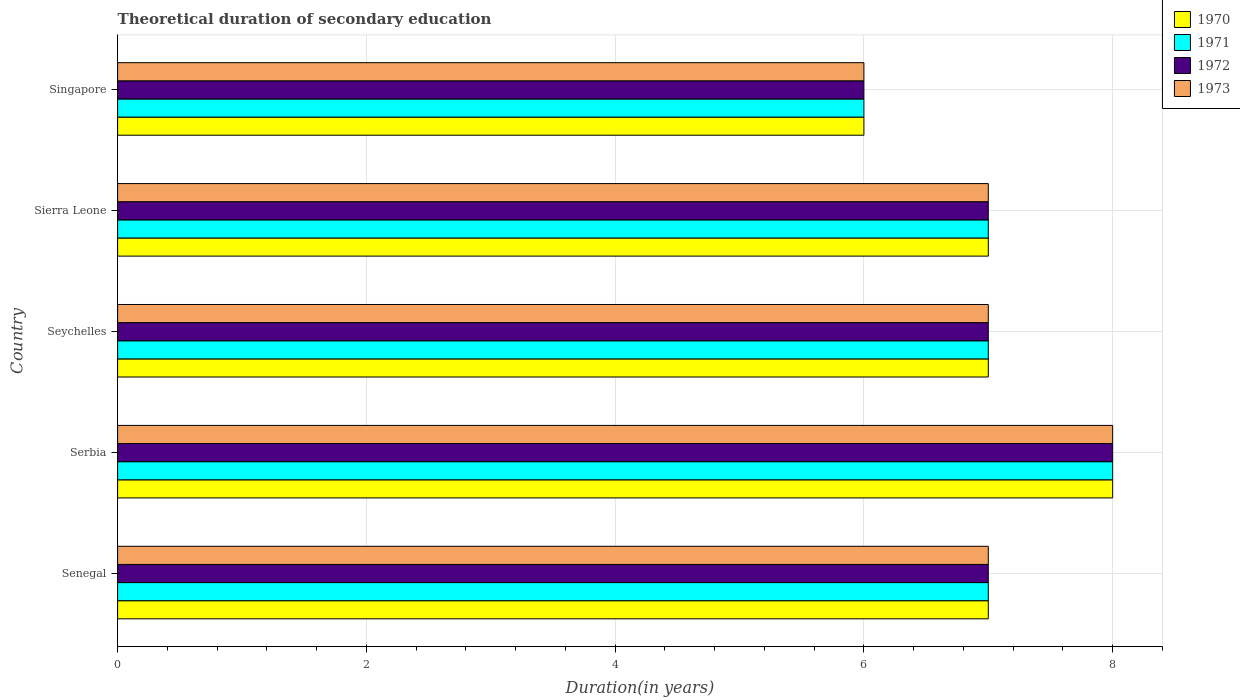How many groups of bars are there?
Offer a very short reply. 5. Are the number of bars per tick equal to the number of legend labels?
Keep it short and to the point. Yes. What is the label of the 1st group of bars from the top?
Make the answer very short. Singapore. Across all countries, what is the maximum total theoretical duration of secondary education in 1970?
Your answer should be very brief. 8. In which country was the total theoretical duration of secondary education in 1971 maximum?
Give a very brief answer. Serbia. In which country was the total theoretical duration of secondary education in 1973 minimum?
Your response must be concise. Singapore. What is the total total theoretical duration of secondary education in 1971 in the graph?
Your response must be concise. 35. In how many countries, is the total theoretical duration of secondary education in 1972 greater than 8 years?
Ensure brevity in your answer.  0. Is the total theoretical duration of secondary education in 1971 in Serbia less than that in Seychelles?
Make the answer very short. No. What is the difference between the highest and the second highest total theoretical duration of secondary education in 1971?
Your response must be concise. 1. What is the difference between the highest and the lowest total theoretical duration of secondary education in 1971?
Keep it short and to the point. 2. Is it the case that in every country, the sum of the total theoretical duration of secondary education in 1973 and total theoretical duration of secondary education in 1970 is greater than the sum of total theoretical duration of secondary education in 1972 and total theoretical duration of secondary education in 1971?
Offer a very short reply. No. What does the 3rd bar from the bottom in Senegal represents?
Keep it short and to the point. 1972. How many bars are there?
Give a very brief answer. 20. Are all the bars in the graph horizontal?
Provide a succinct answer. Yes. How many countries are there in the graph?
Provide a succinct answer. 5. Are the values on the major ticks of X-axis written in scientific E-notation?
Offer a very short reply. No. Where does the legend appear in the graph?
Ensure brevity in your answer.  Top right. How many legend labels are there?
Your response must be concise. 4. How are the legend labels stacked?
Give a very brief answer. Vertical. What is the title of the graph?
Make the answer very short. Theoretical duration of secondary education. Does "1992" appear as one of the legend labels in the graph?
Your answer should be compact. No. What is the label or title of the X-axis?
Offer a very short reply. Duration(in years). What is the label or title of the Y-axis?
Provide a short and direct response. Country. What is the Duration(in years) in 1971 in Senegal?
Make the answer very short. 7. What is the Duration(in years) in 1972 in Senegal?
Offer a terse response. 7. What is the Duration(in years) of 1972 in Serbia?
Offer a very short reply. 8. What is the Duration(in years) in 1972 in Seychelles?
Keep it short and to the point. 7. What is the Duration(in years) in 1973 in Seychelles?
Ensure brevity in your answer.  7. What is the Duration(in years) in 1971 in Sierra Leone?
Your answer should be very brief. 7. What is the Duration(in years) in 1972 in Sierra Leone?
Offer a terse response. 7. What is the Duration(in years) of 1970 in Singapore?
Your answer should be compact. 6. What is the Duration(in years) in 1973 in Singapore?
Make the answer very short. 6. Across all countries, what is the maximum Duration(in years) of 1970?
Your response must be concise. 8. Across all countries, what is the maximum Duration(in years) of 1971?
Give a very brief answer. 8. Across all countries, what is the maximum Duration(in years) in 1972?
Ensure brevity in your answer.  8. Across all countries, what is the minimum Duration(in years) of 1970?
Give a very brief answer. 6. What is the total Duration(in years) in 1972 in the graph?
Your answer should be compact. 35. What is the difference between the Duration(in years) in 1970 in Senegal and that in Serbia?
Offer a terse response. -1. What is the difference between the Duration(in years) in 1971 in Senegal and that in Serbia?
Ensure brevity in your answer.  -1. What is the difference between the Duration(in years) of 1972 in Senegal and that in Serbia?
Offer a terse response. -1. What is the difference between the Duration(in years) of 1973 in Senegal and that in Serbia?
Your answer should be compact. -1. What is the difference between the Duration(in years) in 1970 in Senegal and that in Seychelles?
Offer a terse response. 0. What is the difference between the Duration(in years) in 1971 in Senegal and that in Seychelles?
Provide a short and direct response. 0. What is the difference between the Duration(in years) in 1973 in Senegal and that in Seychelles?
Keep it short and to the point. 0. What is the difference between the Duration(in years) in 1971 in Senegal and that in Sierra Leone?
Offer a terse response. 0. What is the difference between the Duration(in years) of 1972 in Senegal and that in Sierra Leone?
Offer a terse response. 0. What is the difference between the Duration(in years) in 1970 in Senegal and that in Singapore?
Ensure brevity in your answer.  1. What is the difference between the Duration(in years) of 1973 in Senegal and that in Singapore?
Your answer should be very brief. 1. What is the difference between the Duration(in years) in 1971 in Serbia and that in Seychelles?
Your response must be concise. 1. What is the difference between the Duration(in years) of 1972 in Serbia and that in Seychelles?
Keep it short and to the point. 1. What is the difference between the Duration(in years) of 1970 in Serbia and that in Sierra Leone?
Ensure brevity in your answer.  1. What is the difference between the Duration(in years) of 1971 in Serbia and that in Sierra Leone?
Offer a very short reply. 1. What is the difference between the Duration(in years) of 1972 in Serbia and that in Sierra Leone?
Offer a terse response. 1. What is the difference between the Duration(in years) in 1971 in Serbia and that in Singapore?
Your answer should be compact. 2. What is the difference between the Duration(in years) of 1972 in Serbia and that in Singapore?
Your answer should be very brief. 2. What is the difference between the Duration(in years) of 1971 in Seychelles and that in Sierra Leone?
Provide a succinct answer. 0. What is the difference between the Duration(in years) of 1973 in Seychelles and that in Sierra Leone?
Offer a terse response. 0. What is the difference between the Duration(in years) of 1970 in Seychelles and that in Singapore?
Provide a short and direct response. 1. What is the difference between the Duration(in years) in 1971 in Seychelles and that in Singapore?
Your answer should be compact. 1. What is the difference between the Duration(in years) of 1973 in Seychelles and that in Singapore?
Make the answer very short. 1. What is the difference between the Duration(in years) of 1970 in Sierra Leone and that in Singapore?
Give a very brief answer. 1. What is the difference between the Duration(in years) in 1971 in Sierra Leone and that in Singapore?
Offer a terse response. 1. What is the difference between the Duration(in years) in 1970 in Senegal and the Duration(in years) in 1971 in Serbia?
Make the answer very short. -1. What is the difference between the Duration(in years) of 1970 in Senegal and the Duration(in years) of 1972 in Serbia?
Your answer should be very brief. -1. What is the difference between the Duration(in years) of 1970 in Senegal and the Duration(in years) of 1973 in Serbia?
Provide a succinct answer. -1. What is the difference between the Duration(in years) in 1971 in Senegal and the Duration(in years) in 1972 in Serbia?
Ensure brevity in your answer.  -1. What is the difference between the Duration(in years) in 1970 in Senegal and the Duration(in years) in 1971 in Seychelles?
Give a very brief answer. 0. What is the difference between the Duration(in years) in 1970 in Senegal and the Duration(in years) in 1973 in Seychelles?
Ensure brevity in your answer.  0. What is the difference between the Duration(in years) of 1972 in Senegal and the Duration(in years) of 1973 in Seychelles?
Your answer should be compact. 0. What is the difference between the Duration(in years) in 1971 in Senegal and the Duration(in years) in 1972 in Sierra Leone?
Give a very brief answer. 0. What is the difference between the Duration(in years) of 1971 in Senegal and the Duration(in years) of 1973 in Sierra Leone?
Ensure brevity in your answer.  0. What is the difference between the Duration(in years) in 1972 in Senegal and the Duration(in years) in 1973 in Sierra Leone?
Keep it short and to the point. 0. What is the difference between the Duration(in years) in 1970 in Senegal and the Duration(in years) in 1971 in Singapore?
Make the answer very short. 1. What is the difference between the Duration(in years) in 1971 in Senegal and the Duration(in years) in 1973 in Singapore?
Give a very brief answer. 1. What is the difference between the Duration(in years) of 1972 in Senegal and the Duration(in years) of 1973 in Singapore?
Make the answer very short. 1. What is the difference between the Duration(in years) in 1970 in Serbia and the Duration(in years) in 1971 in Seychelles?
Offer a very short reply. 1. What is the difference between the Duration(in years) in 1970 in Serbia and the Duration(in years) in 1972 in Seychelles?
Offer a terse response. 1. What is the difference between the Duration(in years) of 1970 in Serbia and the Duration(in years) of 1973 in Seychelles?
Offer a very short reply. 1. What is the difference between the Duration(in years) in 1972 in Serbia and the Duration(in years) in 1973 in Seychelles?
Provide a succinct answer. 1. What is the difference between the Duration(in years) of 1970 in Serbia and the Duration(in years) of 1973 in Sierra Leone?
Provide a succinct answer. 1. What is the difference between the Duration(in years) in 1970 in Serbia and the Duration(in years) in 1971 in Singapore?
Ensure brevity in your answer.  2. What is the difference between the Duration(in years) in 1970 in Serbia and the Duration(in years) in 1972 in Singapore?
Keep it short and to the point. 2. What is the difference between the Duration(in years) of 1971 in Serbia and the Duration(in years) of 1973 in Singapore?
Offer a terse response. 2. What is the difference between the Duration(in years) of 1970 in Seychelles and the Duration(in years) of 1971 in Sierra Leone?
Offer a terse response. 0. What is the difference between the Duration(in years) of 1970 in Seychelles and the Duration(in years) of 1973 in Sierra Leone?
Provide a succinct answer. 0. What is the difference between the Duration(in years) in 1971 in Seychelles and the Duration(in years) in 1972 in Sierra Leone?
Make the answer very short. 0. What is the difference between the Duration(in years) in 1972 in Seychelles and the Duration(in years) in 1973 in Sierra Leone?
Keep it short and to the point. 0. What is the difference between the Duration(in years) in 1970 in Seychelles and the Duration(in years) in 1973 in Singapore?
Offer a terse response. 1. What is the difference between the Duration(in years) in 1971 in Seychelles and the Duration(in years) in 1973 in Singapore?
Provide a short and direct response. 1. What is the difference between the Duration(in years) in 1972 in Seychelles and the Duration(in years) in 1973 in Singapore?
Keep it short and to the point. 1. What is the difference between the Duration(in years) in 1971 in Sierra Leone and the Duration(in years) in 1972 in Singapore?
Provide a succinct answer. 1. What is the difference between the Duration(in years) in 1971 in Sierra Leone and the Duration(in years) in 1973 in Singapore?
Your response must be concise. 1. What is the difference between the Duration(in years) of 1972 in Sierra Leone and the Duration(in years) of 1973 in Singapore?
Offer a terse response. 1. What is the average Duration(in years) of 1970 per country?
Keep it short and to the point. 7. What is the average Duration(in years) of 1971 per country?
Provide a short and direct response. 7. What is the average Duration(in years) in 1973 per country?
Your answer should be compact. 7. What is the difference between the Duration(in years) of 1970 and Duration(in years) of 1972 in Senegal?
Give a very brief answer. 0. What is the difference between the Duration(in years) in 1971 and Duration(in years) in 1973 in Senegal?
Give a very brief answer. 0. What is the difference between the Duration(in years) in 1972 and Duration(in years) in 1973 in Senegal?
Provide a short and direct response. 0. What is the difference between the Duration(in years) of 1971 and Duration(in years) of 1973 in Serbia?
Keep it short and to the point. 0. What is the difference between the Duration(in years) in 1972 and Duration(in years) in 1973 in Serbia?
Your answer should be compact. 0. What is the difference between the Duration(in years) of 1970 and Duration(in years) of 1972 in Seychelles?
Your response must be concise. 0. What is the difference between the Duration(in years) of 1971 and Duration(in years) of 1972 in Seychelles?
Ensure brevity in your answer.  0. What is the difference between the Duration(in years) in 1971 and Duration(in years) in 1973 in Seychelles?
Your answer should be very brief. 0. What is the difference between the Duration(in years) in 1970 and Duration(in years) in 1971 in Sierra Leone?
Offer a very short reply. 0. What is the difference between the Duration(in years) in 1970 and Duration(in years) in 1972 in Sierra Leone?
Offer a terse response. 0. What is the difference between the Duration(in years) in 1970 and Duration(in years) in 1973 in Sierra Leone?
Offer a terse response. 0. What is the difference between the Duration(in years) of 1971 and Duration(in years) of 1972 in Sierra Leone?
Your answer should be compact. 0. What is the difference between the Duration(in years) of 1970 and Duration(in years) of 1971 in Singapore?
Offer a terse response. 0. What is the difference between the Duration(in years) of 1970 and Duration(in years) of 1972 in Singapore?
Provide a short and direct response. 0. What is the difference between the Duration(in years) in 1971 and Duration(in years) in 1972 in Singapore?
Keep it short and to the point. 0. What is the difference between the Duration(in years) in 1972 and Duration(in years) in 1973 in Singapore?
Make the answer very short. 0. What is the ratio of the Duration(in years) in 1972 in Senegal to that in Serbia?
Your answer should be very brief. 0.88. What is the ratio of the Duration(in years) of 1973 in Senegal to that in Seychelles?
Offer a terse response. 1. What is the ratio of the Duration(in years) in 1972 in Senegal to that in Sierra Leone?
Provide a short and direct response. 1. What is the ratio of the Duration(in years) in 1970 in Senegal to that in Singapore?
Your answer should be very brief. 1.17. What is the ratio of the Duration(in years) of 1971 in Senegal to that in Singapore?
Provide a short and direct response. 1.17. What is the ratio of the Duration(in years) in 1971 in Serbia to that in Seychelles?
Give a very brief answer. 1.14. What is the ratio of the Duration(in years) in 1972 in Serbia to that in Seychelles?
Provide a short and direct response. 1.14. What is the ratio of the Duration(in years) in 1973 in Serbia to that in Seychelles?
Offer a terse response. 1.14. What is the ratio of the Duration(in years) in 1972 in Seychelles to that in Sierra Leone?
Your answer should be compact. 1. What is the ratio of the Duration(in years) of 1970 in Seychelles to that in Singapore?
Give a very brief answer. 1.17. What is the ratio of the Duration(in years) of 1971 in Seychelles to that in Singapore?
Your response must be concise. 1.17. What is the ratio of the Duration(in years) of 1973 in Seychelles to that in Singapore?
Make the answer very short. 1.17. What is the ratio of the Duration(in years) in 1971 in Sierra Leone to that in Singapore?
Provide a succinct answer. 1.17. What is the ratio of the Duration(in years) of 1972 in Sierra Leone to that in Singapore?
Keep it short and to the point. 1.17. What is the ratio of the Duration(in years) in 1973 in Sierra Leone to that in Singapore?
Ensure brevity in your answer.  1.17. What is the difference between the highest and the second highest Duration(in years) in 1971?
Your answer should be compact. 1. What is the difference between the highest and the lowest Duration(in years) in 1970?
Your response must be concise. 2. What is the difference between the highest and the lowest Duration(in years) of 1971?
Give a very brief answer. 2. 